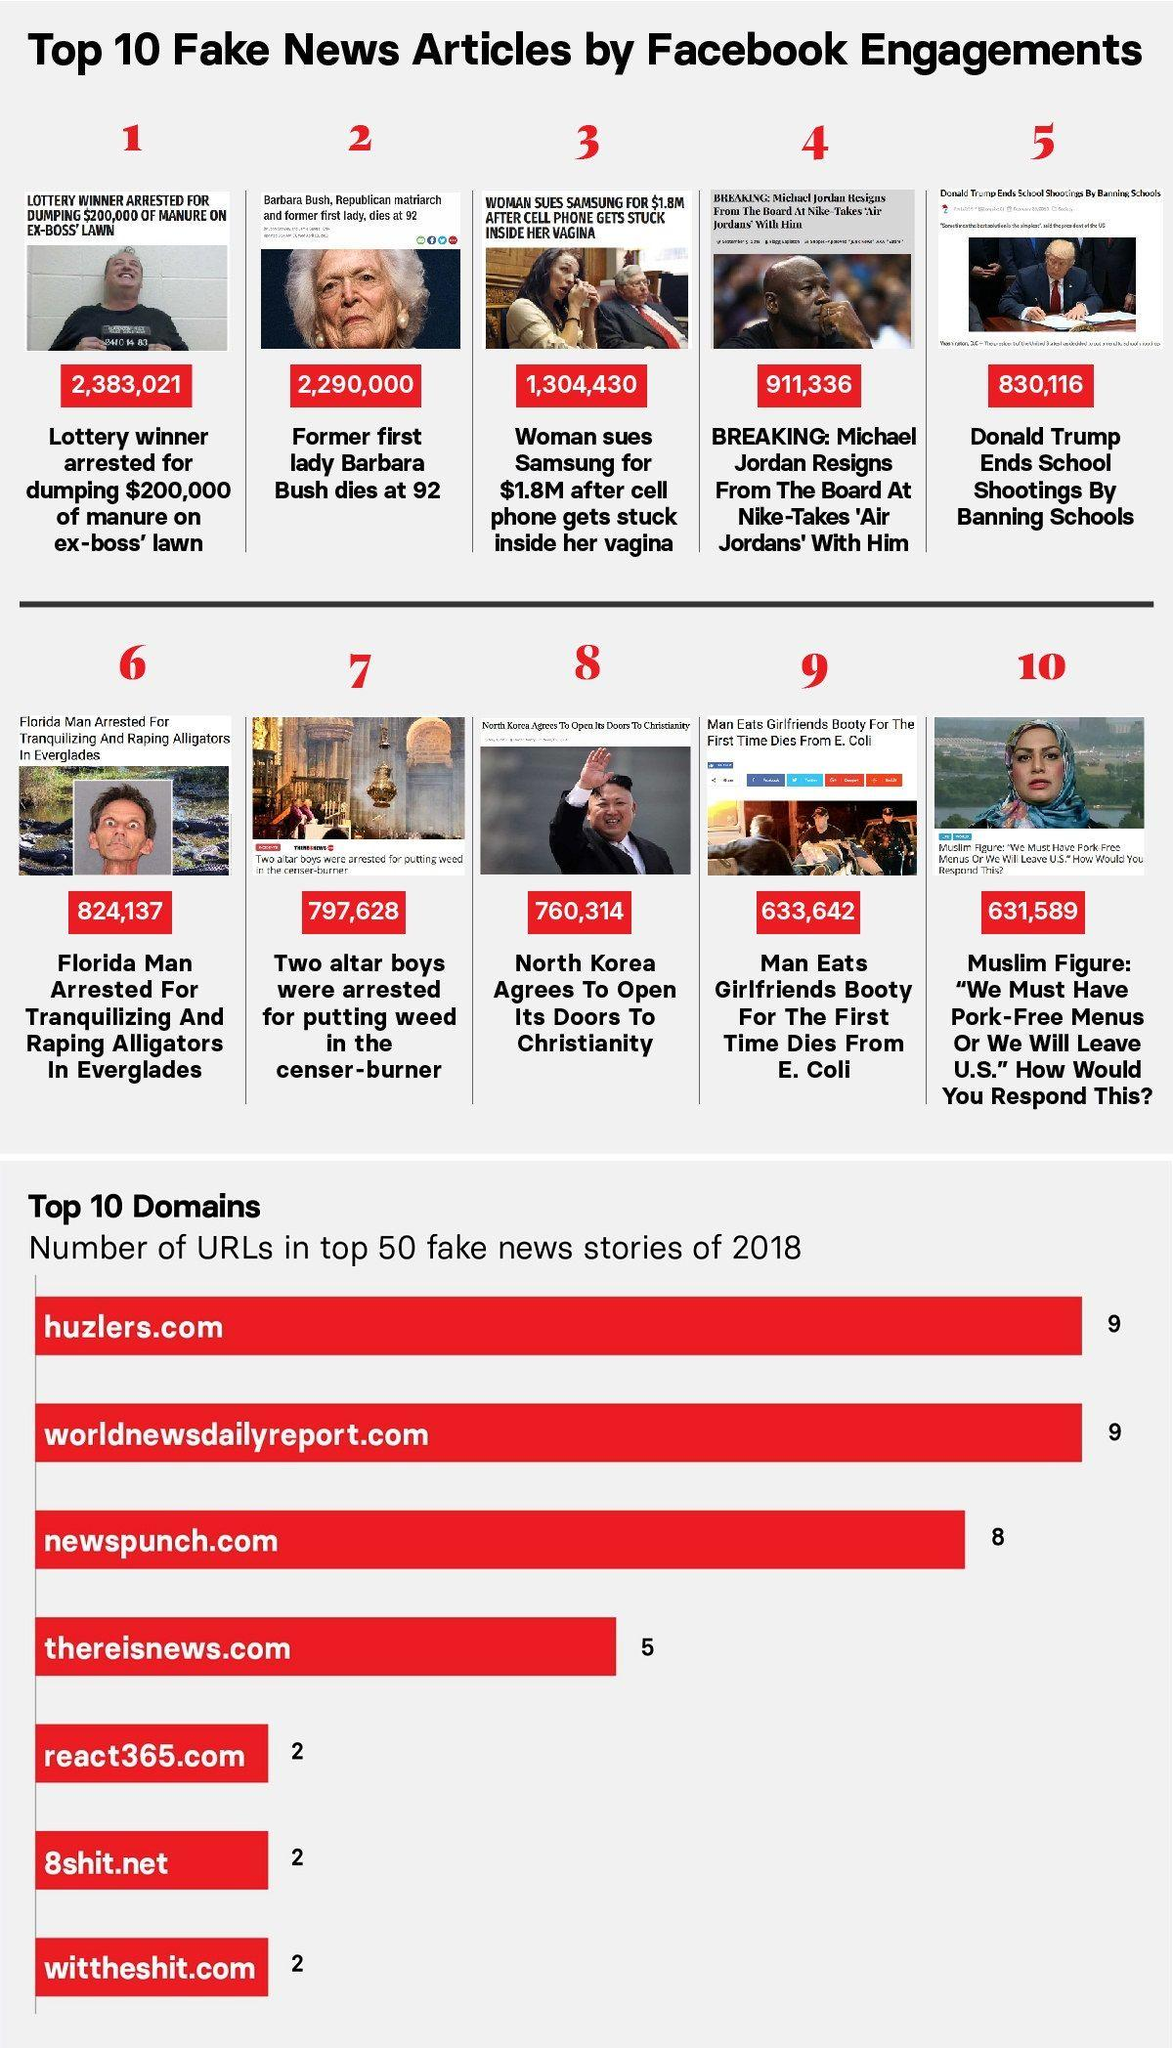Identify some key points in this picture. The total number of URLs in newspunch.com and thereisnews.com is 13. The combined number of URLs on the websites "huzlers.com" and "wittheshit.com" is 11. The number of URLs in the websites react365.com and 8shit.net taken together is four. 